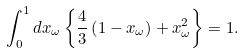<formula> <loc_0><loc_0><loc_500><loc_500>\int _ { 0 } ^ { 1 } d x _ { \omega } \left \{ \frac { 4 } { 3 } \left ( 1 - x _ { \omega } \right ) + x _ { \omega } ^ { 2 } \right \} = 1 .</formula> 